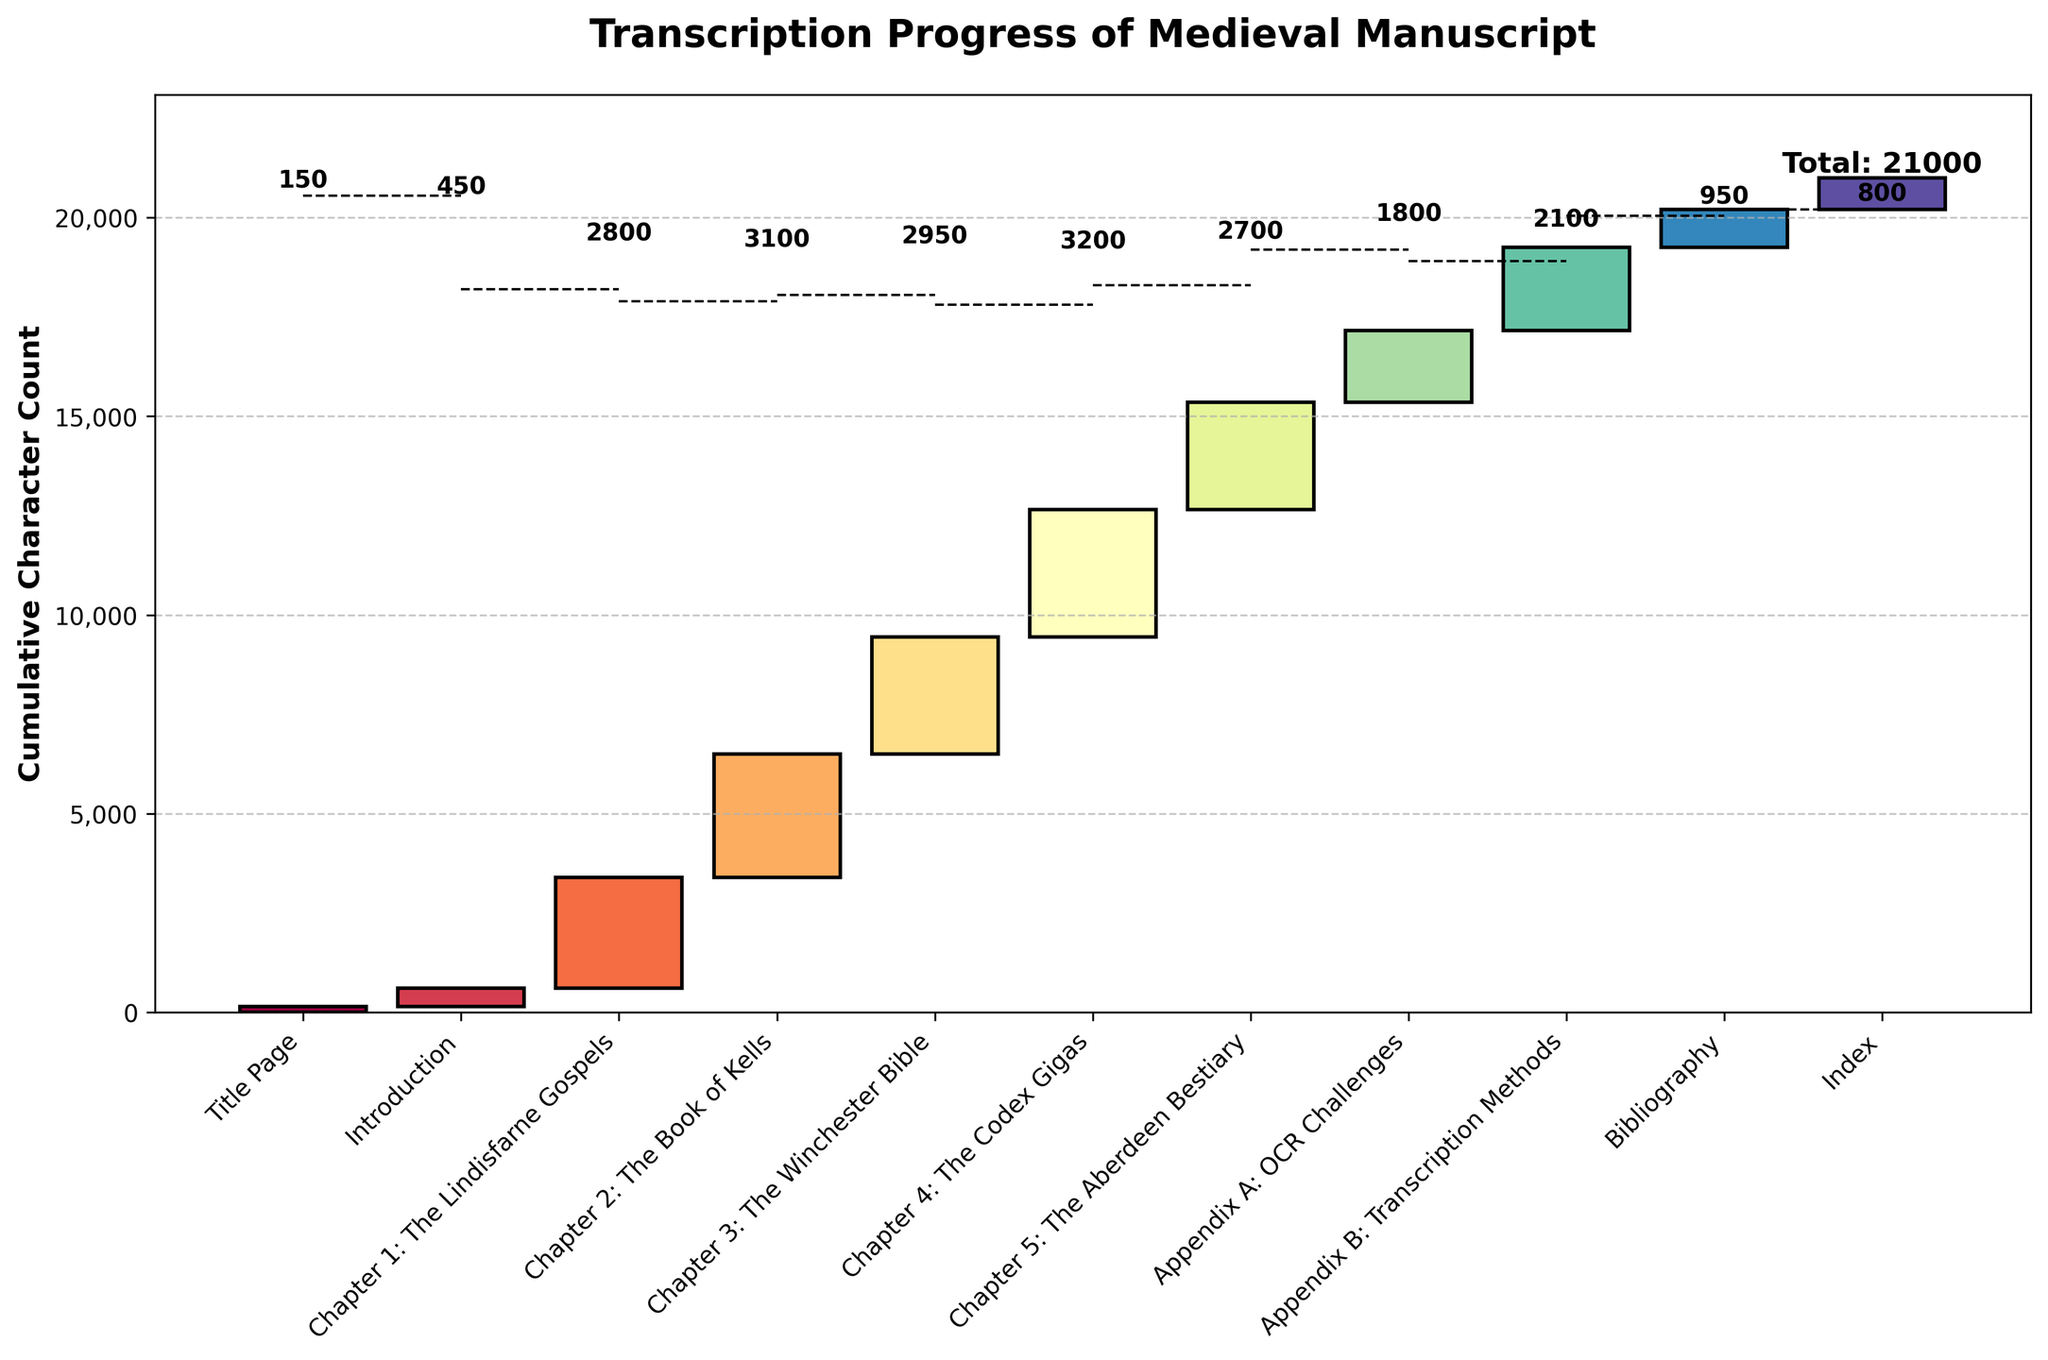What is the title of the chart? The title is written at the top of the chart in bold text. It generally describes the main topic or purpose of the chart.
Answer: Transcription Progress of Medieval Manuscript How many pages are represented in the waterfall chart? Each bar in the waterfall chart represents one page. Counting these bars will give us the number of pages.
Answer: 11 Which page has the highest cumulative character count contribution? The first page has the base character count. Checking the incremental character counts, the page with the largest count is the one with the highest contribution.
Answer: Chapter 2: The Book of Kells What is the cumulative character count at the end of "Chapter 5: The Aberdeen Bestiary"? By looking at the running totals in the data, "Chapter 5: The Aberdeen Bestiary" has a cumulative character count which we can find in the y-axis corresponding to the top of this bar.
Answer: 15350 What is the difference in character count between "Chapter 3: The Winchester Bible" and "Chapter 4: The Codex Gigas"? Subtract the character count of "Chapter 3: The Winchester Bible" from that of "Chapter 4: The Codex Gigas" to find the difference.
Answer: 250 How does the character count of the "Appendix B: Transcription Methods" compare to the "Bibliography"? Compare the height of the bars labeled "Appendix B: Transcription Methods" and "Bibliography". The higher bar represents more characters.
Answer: Appendix B: Transcription Methods has more characters What is the total cumulative character count at the end of the manuscript? The cumulative running total at the very end of the chart represents the total character count summed from all the pages.
Answer: 21000 How many chapters have more than 3000 characters individually? Identify the bars for each chapter and count how many have heights (character counts) greater than 3000.
Answer: 3 chapters (Chapter 2: The Book of Kells, Chapter 4: The Codex Gigas, and Chapter 3: The Winchester Bible) What is the average number of characters per page, excluding the "Index"? Sum the characters for all pages except the "Index" and then divide by the number of pages excluded.
Answer: (20200 - 800) / 10 = 1940 How does the character count progression change from "Introduction” to "Chapter 1: The Lindisfarne Gospels"? Observe the change in character counts between these two sections by noting the difference and the incremental addition in the chart.
Answer: Increase by 2800 If the character count doubled for "Introduction," what would the new cumulative total become after the "Introduction"? Double the character count for "Introduction" and add it to the cumulative total of the previous page, "Title Page".
Answer: 600 + 450 = 1050 